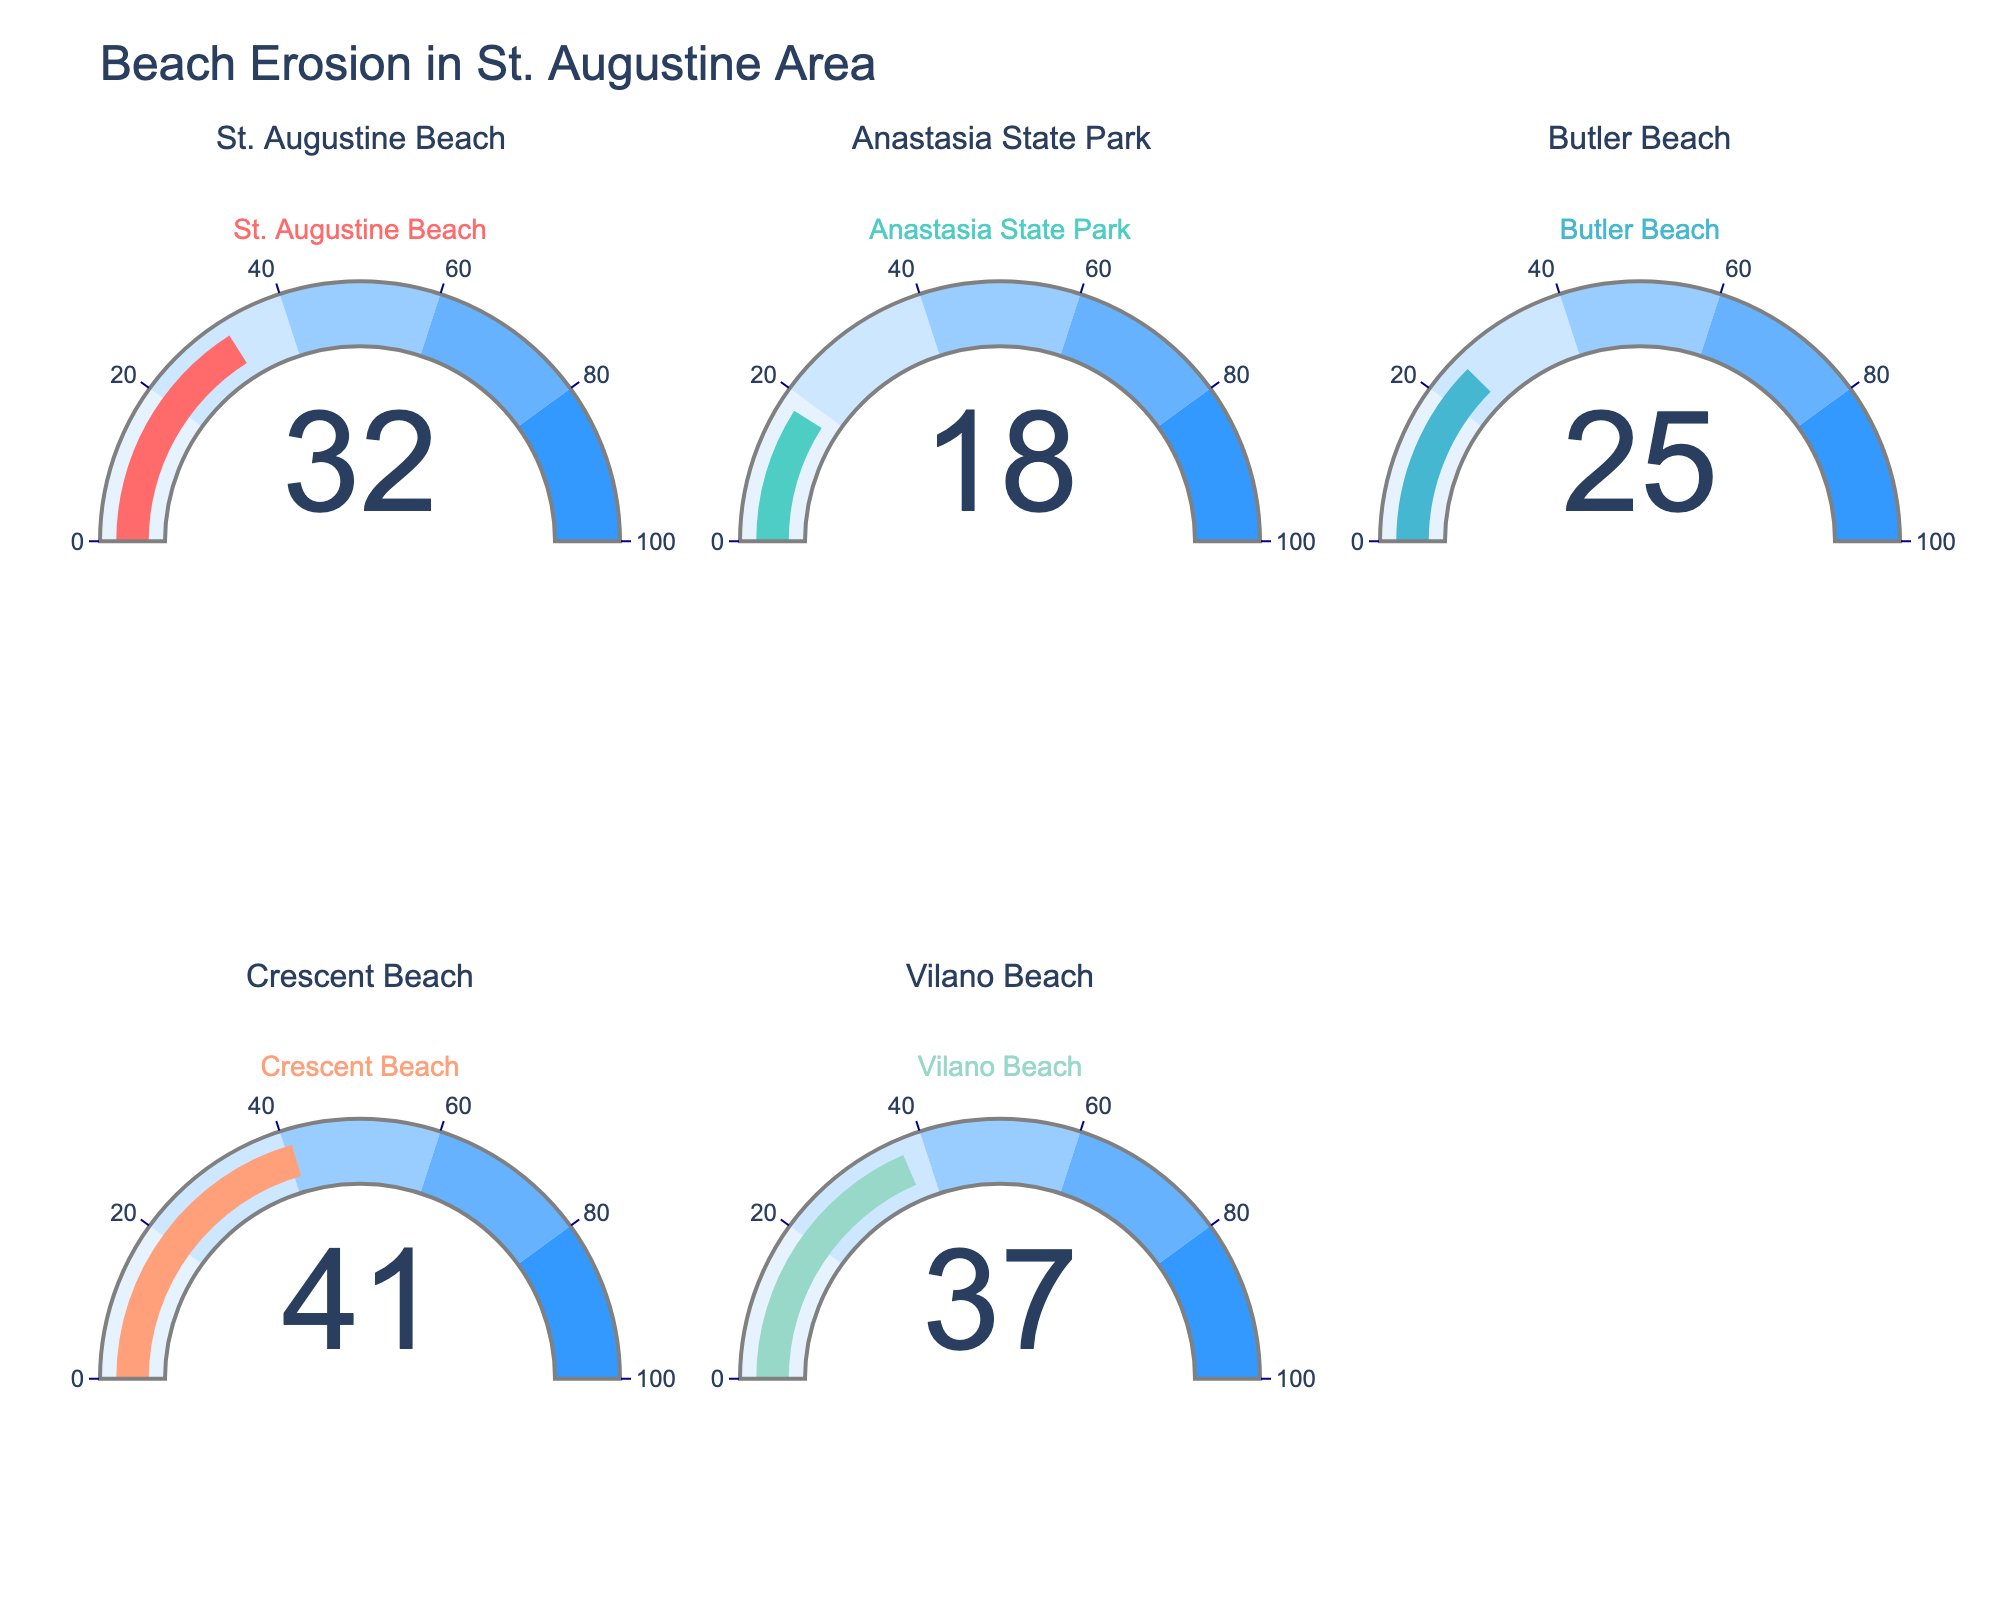What percentage of St. Augustine Beach is affected by erosion? Look at the gauge chart labeled "St. Augustine Beach" and read the number displayed on it.
Answer: 32% Which beach experiences the highest percentage of erosion? Compare the numbers on all gauge charts and identify the highest percentage value. The highest number corresponds to the beach with the most erosion.
Answer: Crescent Beach What is the total percentage of the beach area affected by erosion for all five beaches combined? Sum the percentages from all five beaches: 32% + 18% + 25% + 41% + 37%.
Answer: 153% How does the percentage of erosion in Vilano Beach compare to Butler Beach? Look at the percentages for Vilano Beach and Butler Beach and compare them: Vilano Beach (37%) and Butler Beach (25%). Vilano Beach has a higher percentage.
Answer: Vilano Beach has 12% more erosion than Butler Beach What is the average percentage of erosion across all the beaches? Calculate the average by summing the erosion percentages and dividing by the number of beaches: (32% + 18% + 25% + 41% + 37%) / 5.
Answer: 30.6% Which beaches have more than 30% of their area affected by erosion? Identify the beaches with percentages greater than 30% by inspecting each gauge chart.
Answer: St. Augustine Beach, Crescent Beach, Vilano Beach Which beach has the least amount of area affected by erosion? Compare the numbers on all gauge charts and identify the lowest percentage value, which is the least eroded beach.
Answer: Anastasia State Park Are there any beaches with an equal percentage of erosion? Inspect all the percentages and see if any two gauge charts display the same number.
Answer: No What is the difference in percentage of erosion between the beach with the highest and the lowest erosion? Subtract the lowest percentage (Anastasia State Park, 18%) from the highest percentage (Crescent Beach, 41%).
Answer: 23% If the amount of erosion at Butler Beach increases by 10%, what will be the new percentage? Add 10% to the current percentage of erosion at Butler Beach (25% + 10%).
Answer: 35% 